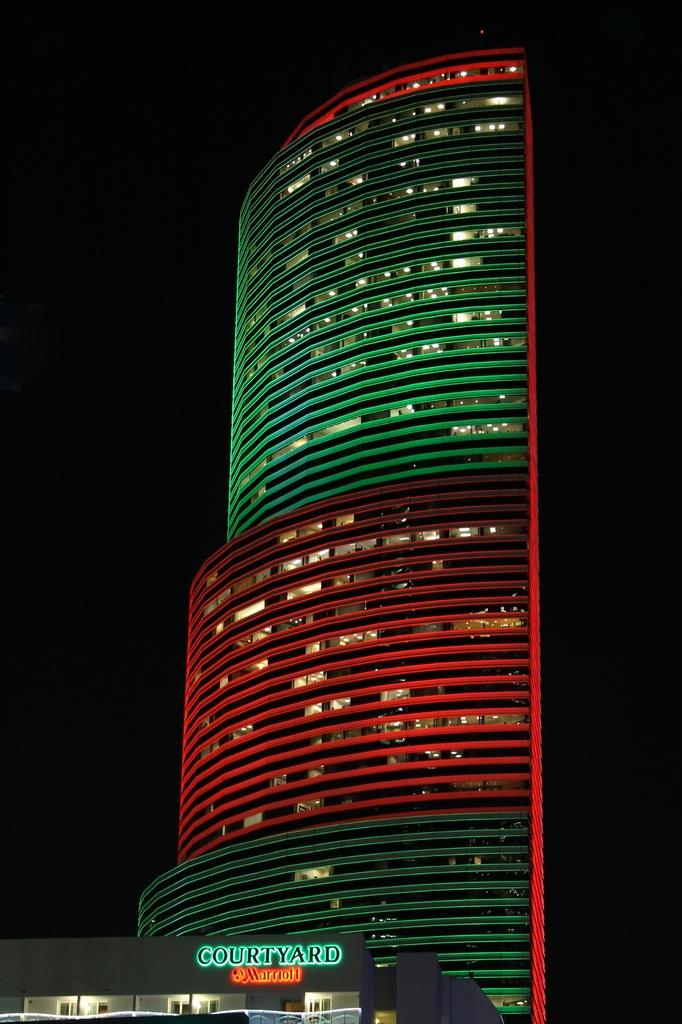What is the main subject of the image? The main subject of the image is a building. Are there any distinguishing features of the building? Yes, the building has lights. Is there any text or label on the building? Yes, there is a name at the bottom of the building in the image. What color is the scarf draped over the building in the image? There is no scarf present in the image. Can you tell me how many wishes are granted to people who look at the building in the image? There is no mention of wishes or their fulfillment in the image. 